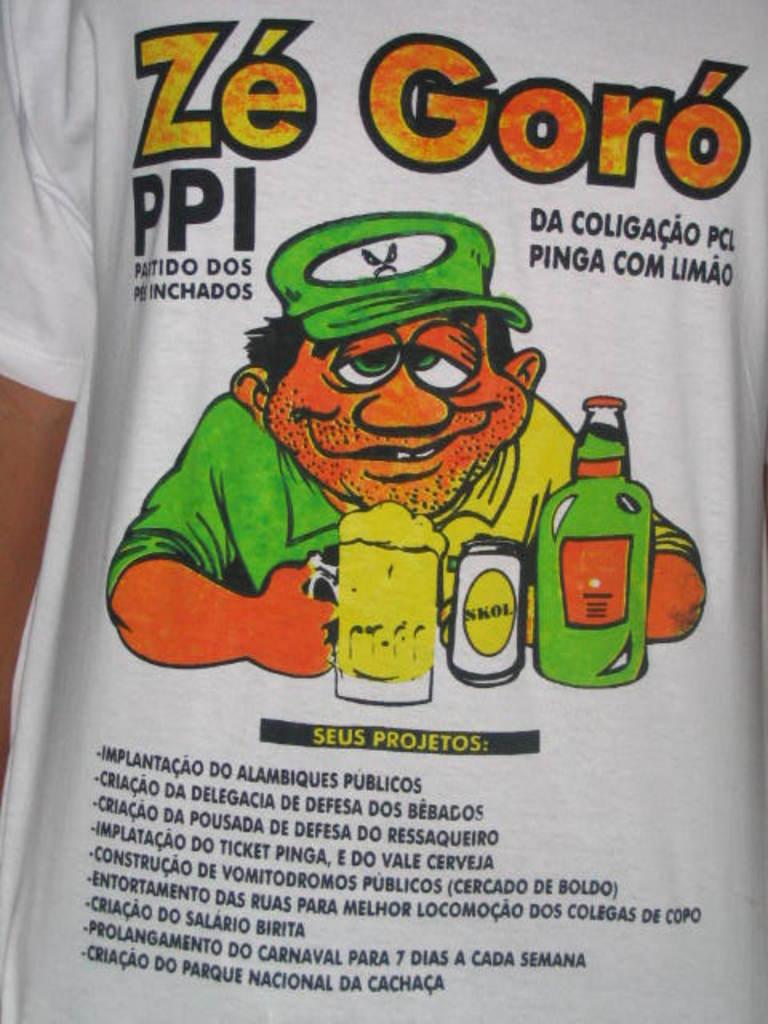Who or what is present in the image? There is a person in the image. What is the person wearing? The person is wearing a white T-shirt. What design is on the T-shirt? The T-shirt has a cartoon printed on it. Are there any words on the T-shirt? Yes, the T-shirt has text printed on it. What type of mine can be seen in the background of the image? There is no mine present in the image; it features a person wearing a T-shirt with a cartoon and text. 